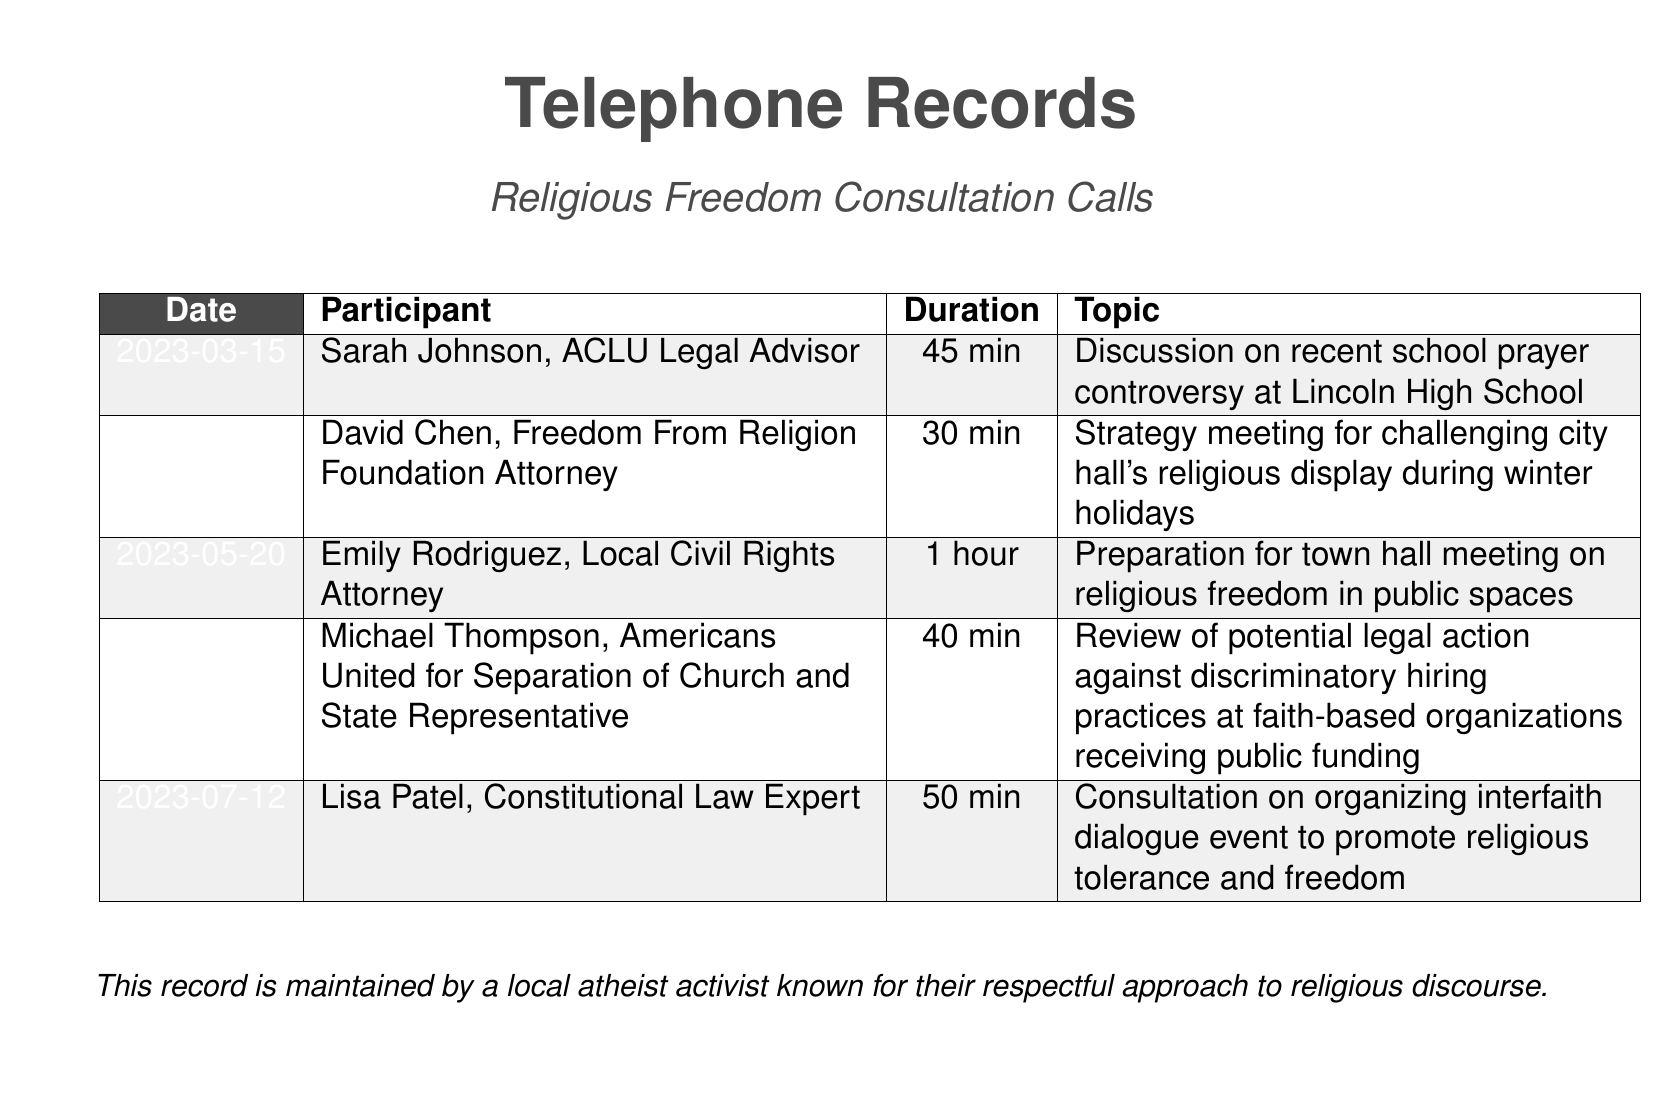What is the date of the consultation with Sarah Johnson? The date for Sarah Johnson's consultation, a legal advisor from ACLU, is listed in the document as 2023-03-15.
Answer: 2023-03-15 Who was involved in the strategy meeting on city hall's religious display? The document indicates that David Chen, an attorney from Freedom From Religion Foundation, participated in the strategy meeting.
Answer: David Chen How long was the call with Emily Rodriguez? The duration of the call with Emily Rodriguez, a local civil rights attorney, is provided as 1 hour.
Answer: 1 hour What was the main topic of the call on June 8, 2023? The document notes that the topic of the call on this date was a review of potential legal action against discriminatory hiring practices.
Answer: Review of potential legal action against discriminatory hiring practices How many total participants are listed in the record? The document outlines five distinct calls involving different participants, totaling five participants.
Answer: Five Is there a call discussing a town hall meeting? Yes, the document states that there is a call discussing preparations for a town hall meeting concerning religious freedom.
Answer: Yes Which organization is represented by Michael Thompson? The participation of Michael Thompson in the call on June 8 is linked to Americans United for Separation of Church and State.
Answer: Americans United for Separation of Church and State What does the document primarily record? The document focuses on the records of telephone consultations regarding religious freedom issues in the community.
Answer: Telephone consultations regarding religious freedom issues 